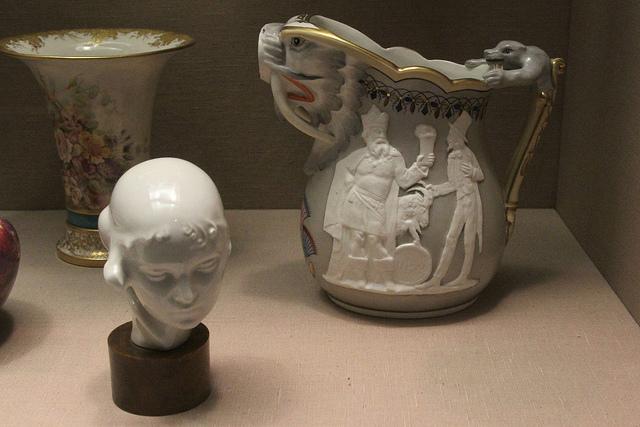How many items are pictured?
Short answer required. 3. Are these made of glass?
Quick response, please. No. Are these antique?
Concise answer only. Yes. How many vase in the picture?
Short answer required. 2. What color is the bust?
Concise answer only. White. 